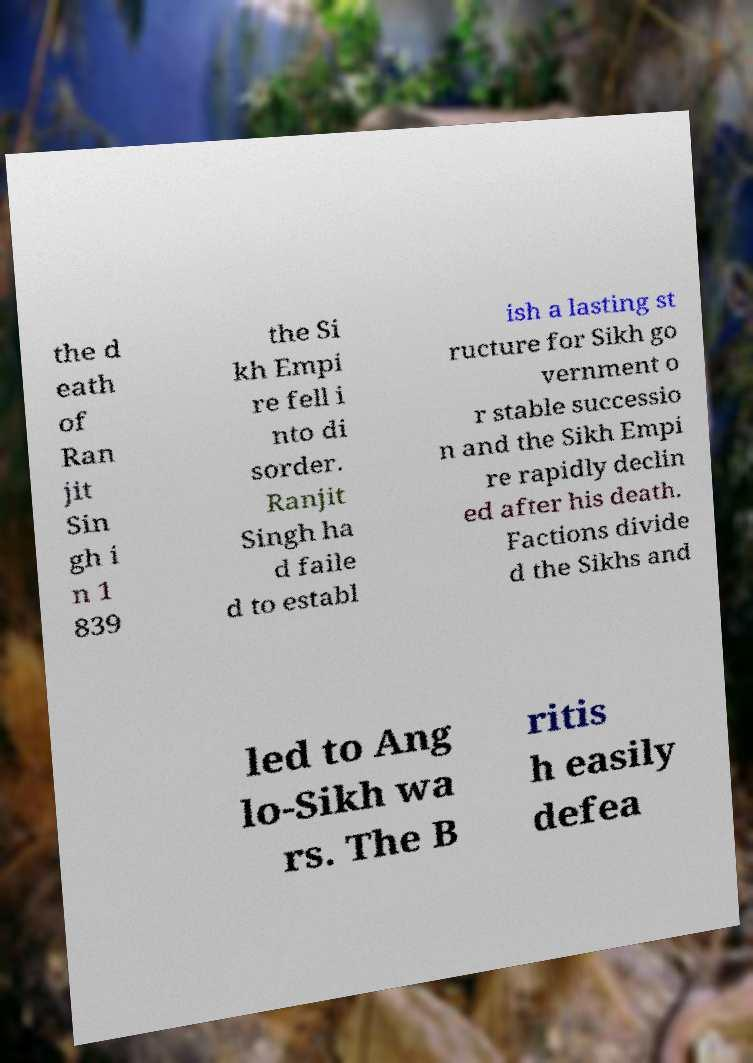Can you read and provide the text displayed in the image?This photo seems to have some interesting text. Can you extract and type it out for me? the d eath of Ran jit Sin gh i n 1 839 the Si kh Empi re fell i nto di sorder. Ranjit Singh ha d faile d to establ ish a lasting st ructure for Sikh go vernment o r stable successio n and the Sikh Empi re rapidly declin ed after his death. Factions divide d the Sikhs and led to Ang lo-Sikh wa rs. The B ritis h easily defea 